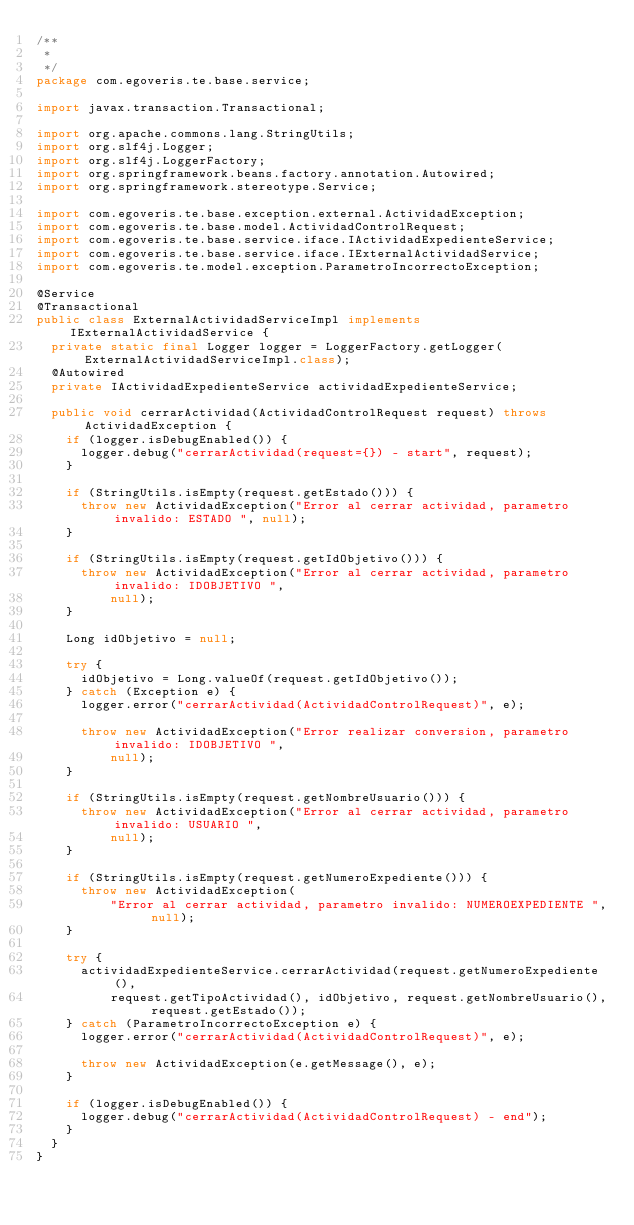Convert code to text. <code><loc_0><loc_0><loc_500><loc_500><_Java_>/**
 * 
 */
package com.egoveris.te.base.service;

import javax.transaction.Transactional;

import org.apache.commons.lang.StringUtils;
import org.slf4j.Logger;
import org.slf4j.LoggerFactory;
import org.springframework.beans.factory.annotation.Autowired;
import org.springframework.stereotype.Service;

import com.egoveris.te.base.exception.external.ActividadException;
import com.egoveris.te.base.model.ActividadControlRequest;
import com.egoveris.te.base.service.iface.IActividadExpedienteService;
import com.egoveris.te.base.service.iface.IExternalActividadService;
import com.egoveris.te.model.exception.ParametroIncorrectoException;

@Service
@Transactional
public class ExternalActividadServiceImpl implements IExternalActividadService {
  private static final Logger logger = LoggerFactory.getLogger(ExternalActividadServiceImpl.class);
  @Autowired
  private IActividadExpedienteService actividadExpedienteService;

  public void cerrarActividad(ActividadControlRequest request) throws ActividadException {
    if (logger.isDebugEnabled()) {
      logger.debug("cerrarActividad(request={}) - start", request);
    }

    if (StringUtils.isEmpty(request.getEstado())) {
      throw new ActividadException("Error al cerrar actividad, parametro invalido: ESTADO ", null);
    }

    if (StringUtils.isEmpty(request.getIdObjetivo())) {
      throw new ActividadException("Error al cerrar actividad, parametro invalido: IDOBJETIVO ",
          null);
    }

    Long idObjetivo = null;

    try {
      idObjetivo = Long.valueOf(request.getIdObjetivo());
    } catch (Exception e) {
      logger.error("cerrarActividad(ActividadControlRequest)", e);

      throw new ActividadException("Error realizar conversion, parametro invalido: IDOBJETIVO ",
          null);
    }

    if (StringUtils.isEmpty(request.getNombreUsuario())) {
      throw new ActividadException("Error al cerrar actividad, parametro invalido: USUARIO ",
          null);
    }

    if (StringUtils.isEmpty(request.getNumeroExpediente())) {
      throw new ActividadException(
          "Error al cerrar actividad, parametro invalido: NUMEROEXPEDIENTE ", null);
    }

    try {
      actividadExpedienteService.cerrarActividad(request.getNumeroExpediente(),
          request.getTipoActividad(), idObjetivo, request.getNombreUsuario(), request.getEstado());
    } catch (ParametroIncorrectoException e) {
      logger.error("cerrarActividad(ActividadControlRequest)", e);

      throw new ActividadException(e.getMessage(), e);
    }

    if (logger.isDebugEnabled()) {
      logger.debug("cerrarActividad(ActividadControlRequest) - end");
    }
  }
}
</code> 